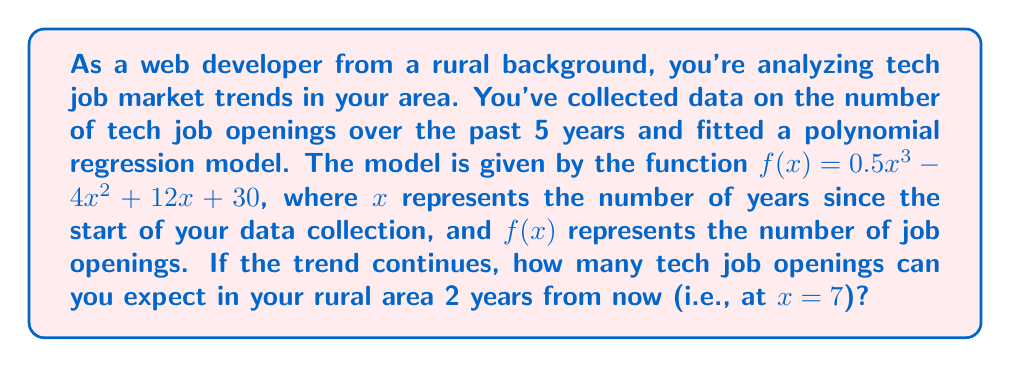Can you solve this math problem? To solve this problem, we need to evaluate the given polynomial function at $x = 7$. Let's break it down step-by-step:

1) The given function is $f(x) = 0.5x^3 - 4x^2 + 12x + 30$

2) We need to calculate $f(7)$, so let's substitute $x$ with 7:

   $f(7) = 0.5(7^3) - 4(7^2) + 12(7) + 30$

3) Let's evaluate each term:
   - $0.5(7^3) = 0.5(343) = 171.5$
   - $4(7^2) = 4(49) = 196$
   - $12(7) = 84$
   - The constant term is already 30

4) Now, let's combine these terms:

   $f(7) = 171.5 - 196 + 84 + 30$

5) Simplifying:

   $f(7) = 89.5$

6) Since we're dealing with job openings, we need to round to the nearest whole number:

   $f(7) \approx 90$

Therefore, based on this polynomial regression model, you can expect approximately 90 tech job openings in your rural area 2 years from now.
Answer: 90 job openings 